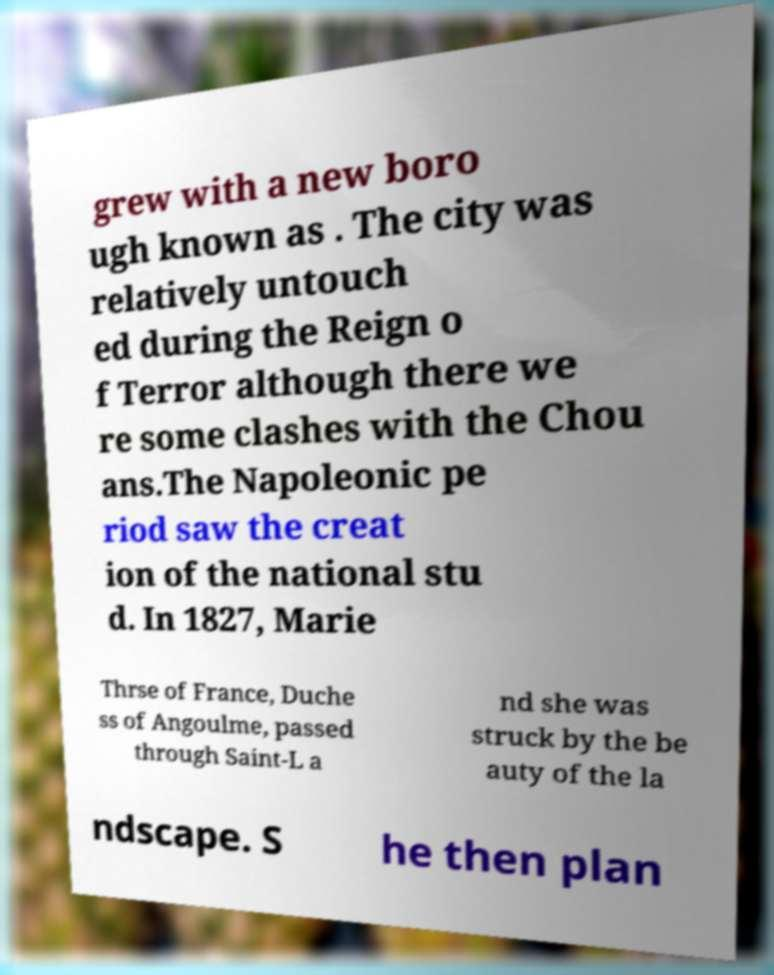Please read and relay the text visible in this image. What does it say? grew with a new boro ugh known as . The city was relatively untouch ed during the Reign o f Terror although there we re some clashes with the Chou ans.The Napoleonic pe riod saw the creat ion of the national stu d. In 1827, Marie Thrse of France, Duche ss of Angoulme, passed through Saint-L a nd she was struck by the be auty of the la ndscape. S he then plan 